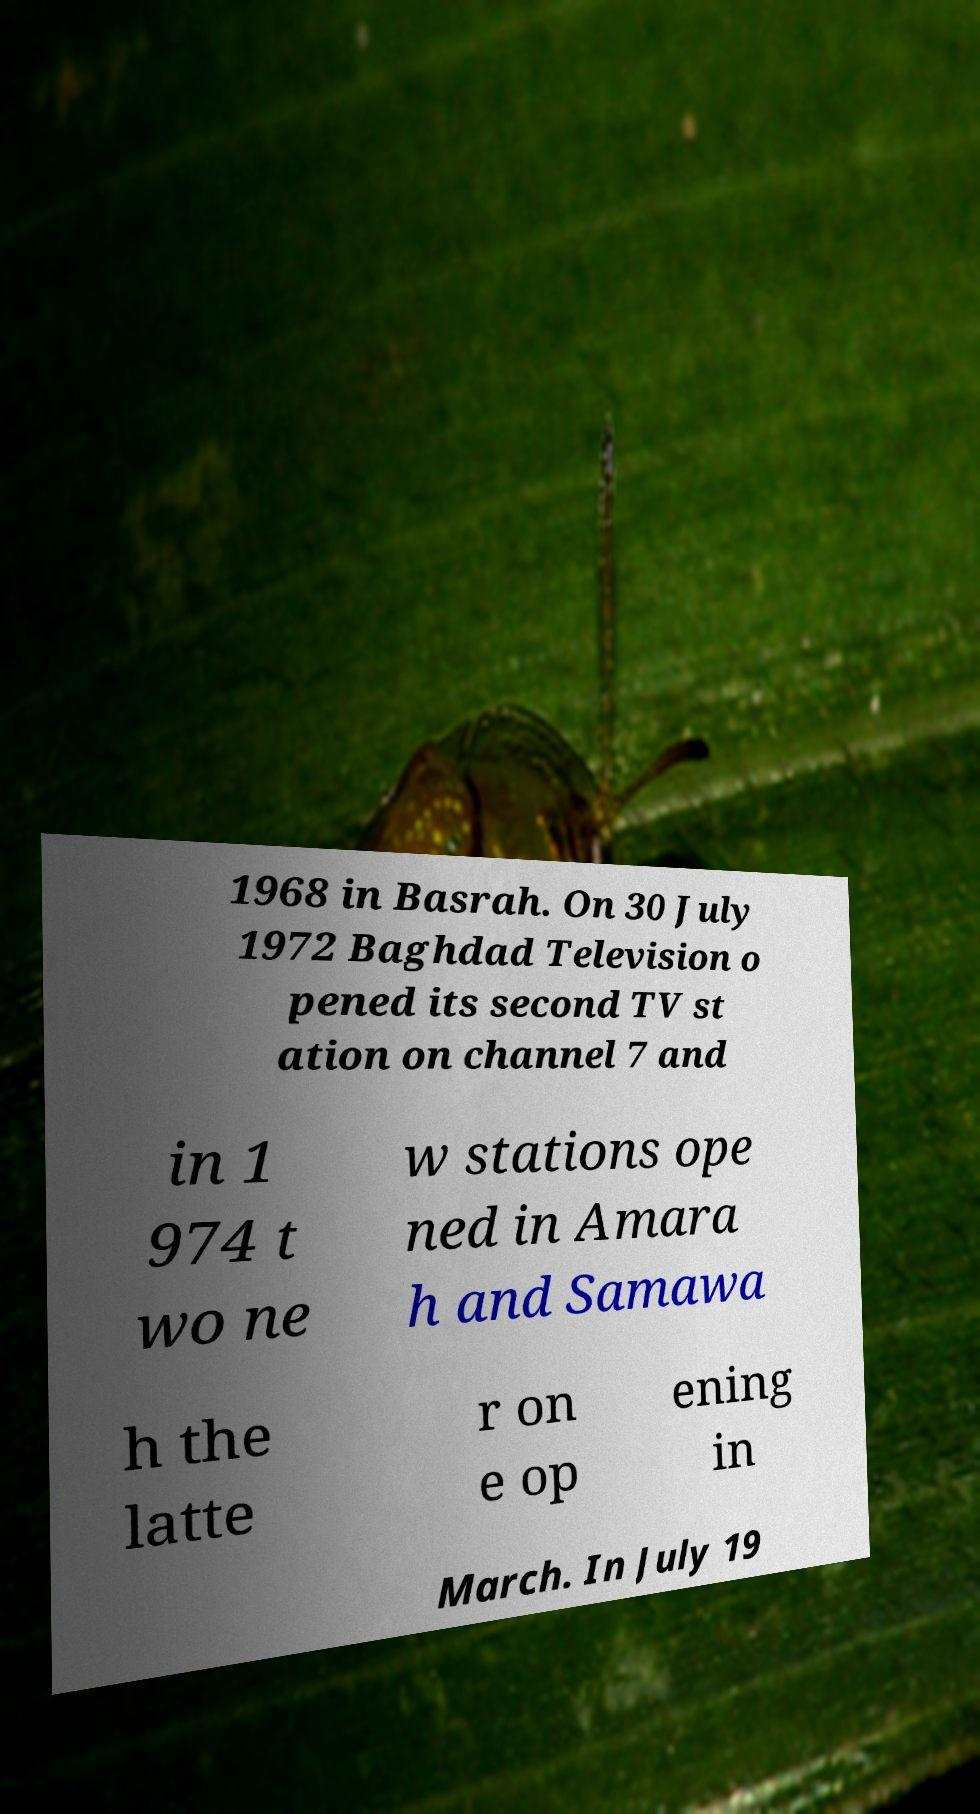Please identify and transcribe the text found in this image. 1968 in Basrah. On 30 July 1972 Baghdad Television o pened its second TV st ation on channel 7 and in 1 974 t wo ne w stations ope ned in Amara h and Samawa h the latte r on e op ening in March. In July 19 